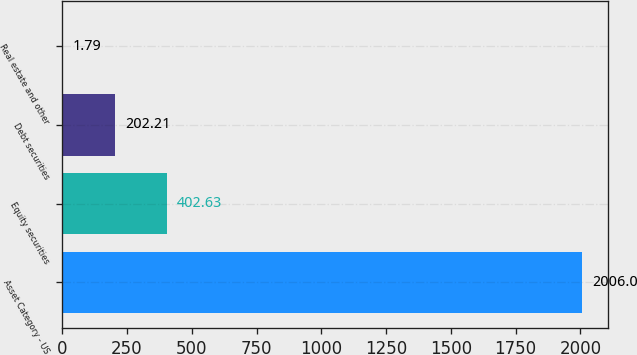Convert chart. <chart><loc_0><loc_0><loc_500><loc_500><bar_chart><fcel>Asset Category - US<fcel>Equity securities<fcel>Debt securities<fcel>Real estate and other<nl><fcel>2006<fcel>402.63<fcel>202.21<fcel>1.79<nl></chart> 